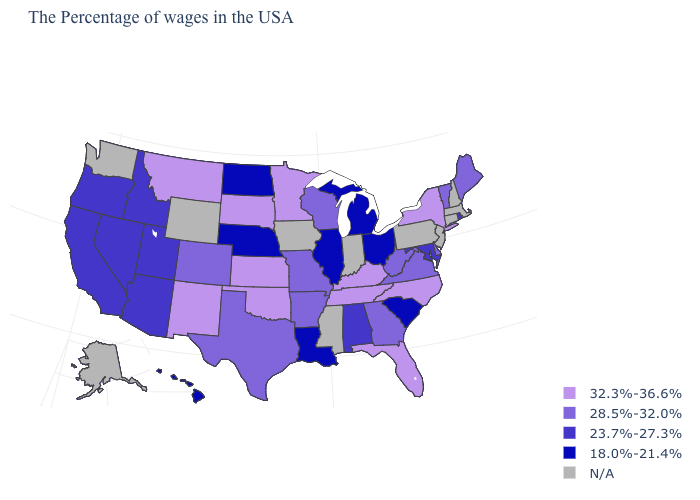What is the value of West Virginia?
Concise answer only. 28.5%-32.0%. What is the value of Wisconsin?
Be succinct. 28.5%-32.0%. What is the value of Rhode Island?
Concise answer only. 23.7%-27.3%. What is the lowest value in the USA?
Quick response, please. 18.0%-21.4%. Which states have the lowest value in the West?
Concise answer only. Hawaii. What is the value of Utah?
Be succinct. 23.7%-27.3%. Name the states that have a value in the range N/A?
Quick response, please. Massachusetts, New Hampshire, Connecticut, New Jersey, Pennsylvania, Indiana, Mississippi, Iowa, Wyoming, Washington, Alaska. Which states have the highest value in the USA?
Answer briefly. New York, North Carolina, Florida, Kentucky, Tennessee, Minnesota, Kansas, Oklahoma, South Dakota, New Mexico, Montana. What is the highest value in the USA?
Short answer required. 32.3%-36.6%. What is the lowest value in the West?
Quick response, please. 18.0%-21.4%. Name the states that have a value in the range 32.3%-36.6%?
Answer briefly. New York, North Carolina, Florida, Kentucky, Tennessee, Minnesota, Kansas, Oklahoma, South Dakota, New Mexico, Montana. Is the legend a continuous bar?
Concise answer only. No. Name the states that have a value in the range 28.5%-32.0%?
Keep it brief. Maine, Vermont, Delaware, Virginia, West Virginia, Georgia, Wisconsin, Missouri, Arkansas, Texas, Colorado. What is the value of Hawaii?
Keep it brief. 18.0%-21.4%. 